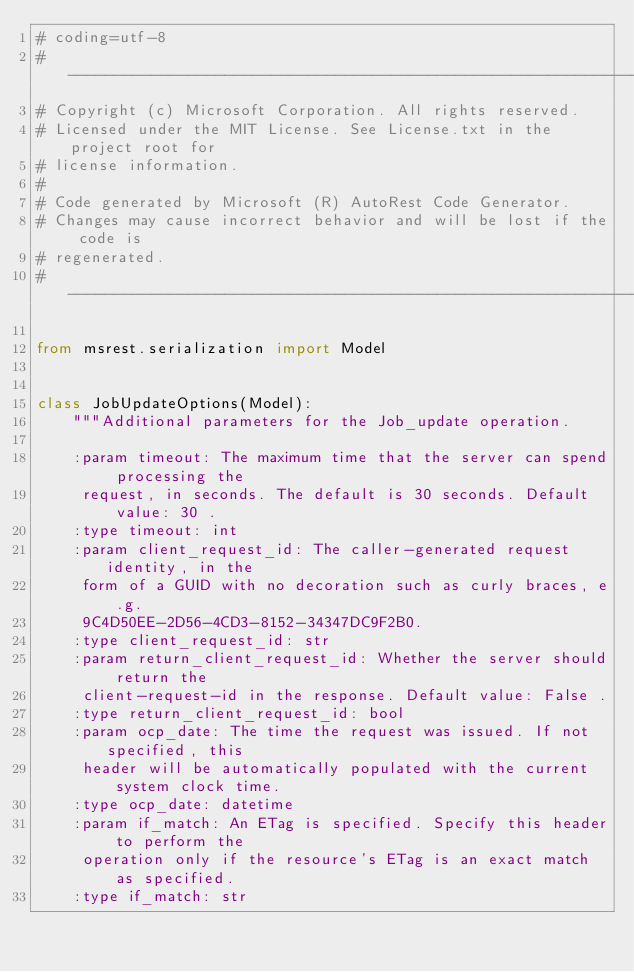<code> <loc_0><loc_0><loc_500><loc_500><_Python_># coding=utf-8
# --------------------------------------------------------------------------
# Copyright (c) Microsoft Corporation. All rights reserved.
# Licensed under the MIT License. See License.txt in the project root for
# license information.
#
# Code generated by Microsoft (R) AutoRest Code Generator.
# Changes may cause incorrect behavior and will be lost if the code is
# regenerated.
# --------------------------------------------------------------------------

from msrest.serialization import Model


class JobUpdateOptions(Model):
    """Additional parameters for the Job_update operation.

    :param timeout: The maximum time that the server can spend processing the
     request, in seconds. The default is 30 seconds. Default value: 30 .
    :type timeout: int
    :param client_request_id: The caller-generated request identity, in the
     form of a GUID with no decoration such as curly braces, e.g.
     9C4D50EE-2D56-4CD3-8152-34347DC9F2B0.
    :type client_request_id: str
    :param return_client_request_id: Whether the server should return the
     client-request-id in the response. Default value: False .
    :type return_client_request_id: bool
    :param ocp_date: The time the request was issued. If not specified, this
     header will be automatically populated with the current system clock time.
    :type ocp_date: datetime
    :param if_match: An ETag is specified. Specify this header to perform the
     operation only if the resource's ETag is an exact match as specified.
    :type if_match: str</code> 